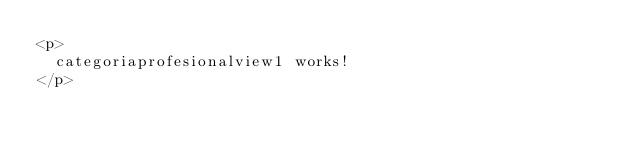Convert code to text. <code><loc_0><loc_0><loc_500><loc_500><_HTML_><p>
  categoriaprofesionalview1 works!
</p>
</code> 